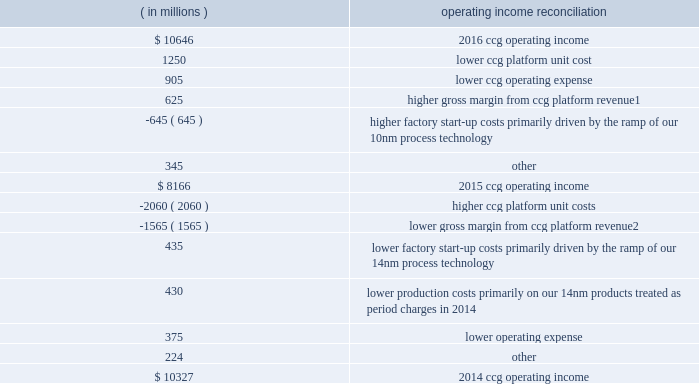Management 2019s discussion and analysis of financial condition and results of operations ( continued ) the following results drove changes in ccg operating income by approximately the amounts indicated: .
1 higher gross margin from higher ccg platform revenue was driven by higher average selling prices on notebook and desktop platforms , offset by lower desktop and notebook platform unit sales .
2 lower gross margin from lower ccg platform revenue was driven by lower desktop and notebook platform unit sales , partially offset by higher average selling prices on desktop , notebook , and tablet platforms .
Data center group segment product overview the dcg operating segment offers platforms designed to provide leading energy-efficient performance for all server , network , and storage applications .
In addition , dcg focuses on lowering the total cost of ownership on other specific workload- optimizations for the enterprise , cloud service providers , and communications service provider market segments .
In 2016 , we launched the following platforms with an array of functionalities and advancements : 2022 intel ae xeon ae processor e5 v4 family , the foundation for high performing clouds and delivers energy-efficient performance for server , network , and storage workloads .
2022 intel xeon processor e7 v4 family , targeted at platforms requiring four or more cpus ; this processor family delivers high performance and is optimized for real-time analytics and in-memory computing , along with industry-leading reliability , availability , and serviceability .
2022 intel ae xeon phi 2122 product family , formerly code-named knights landing , with up to 72 high-performance intel processor cores , integrated memory and fabric , and a common software programming model with intel xeon processors .
The intel xeon phi product family is designed for highly parallel compute and memory bandwidth-intensive workloads .
Intel xeon phi processors are positioned to increase the performance of supercomputers , enabling trillions of calculations per second , and to address emerging data analytics and artificial intelligence solutions .
In 2017 , we expect to release our next generation of intel xeon processors for compute , storage , and network ; a next-generation intel xeon phi processor optimized for deep learning ; and a suite of single-socket products , including next-generation intel xeon e3 processors , next-generation intel atom processors , and next-generation intel xeon-d processors for dense solutions. .
What is the growth rate in ccg operating income in 2015? 
Computations: ((8166 - 10327) / 10327)
Answer: -0.20926. 